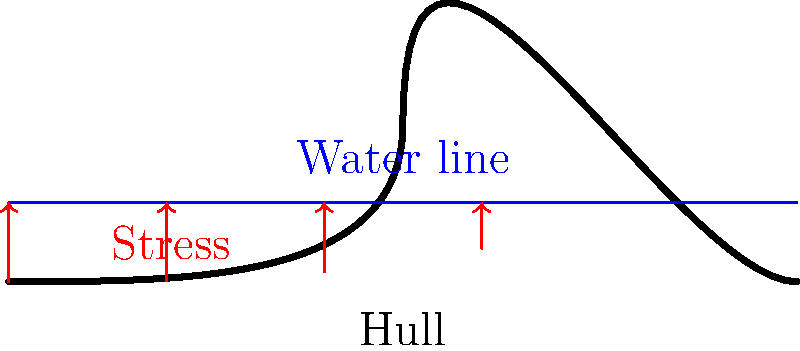As a local business owner in Rogaland, you're interested in the region's Viking heritage. Consider a Viking ship's hull during rough sea conditions. If the water exerts a uniform pressure of $p = 10^5$ Pa on the submerged part of the hull, and the hull's curvature can be approximated by the function $y = 0.004x(100-x)$ for $0 \leq x \leq 100$ (where $x$ and $y$ are in cm), what is the maximum stress $\sigma_{max}$ (in MPa) experienced by the hull? To find the maximum stress on the Viking ship's hull, we'll follow these steps:

1) The stress on the hull is caused by the water pressure. The pressure is uniform, but the stress varies due to the hull's curvature.

2) The stress at any point is related to the pressure and the hull's slope at that point. The relationship is:

   $\sigma = \frac{p}{\cos \theta}$

   where $\theta$ is the angle between the hull's tangent and the horizontal.

3) We need to find the point where the hull's slope is steepest, as this will result in the maximum stress.

4) The hull's shape is given by $y = 0.004x(100-x)$. To find the slope, we differentiate:

   $\frac{dy}{dx} = 0.004(100-2x)$

5) The slope is steepest when $|\frac{dy}{dx}|$ is maximum. This occurs at $x = 0$ or $x = 100$.

6) At these points, $|\frac{dy}{dx}| = 0.4$

7) The angle $\theta$ at these points is:

   $\theta = \arctan(0.4) = 0.3805$ radians

8) Now we can calculate the maximum stress:

   $\sigma_{max} = \frac{p}{\cos(\arctan(0.4))} = \frac{10^5}{\cos(0.3805)} = 1.077 \times 10^5$ Pa

9) Converting to MPa:

   $\sigma_{max} = 0.1077$ MPa
Answer: 0.1077 MPa 